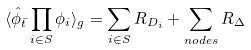<formula> <loc_0><loc_0><loc_500><loc_500>\langle \hat { \phi } _ { \bar { t } } \prod _ { i \in S } \phi _ { i } \rangle _ { g } = \sum _ { i \in S } R _ { D _ { i } } + \sum _ { n o d e s } R _ { \Delta }</formula> 